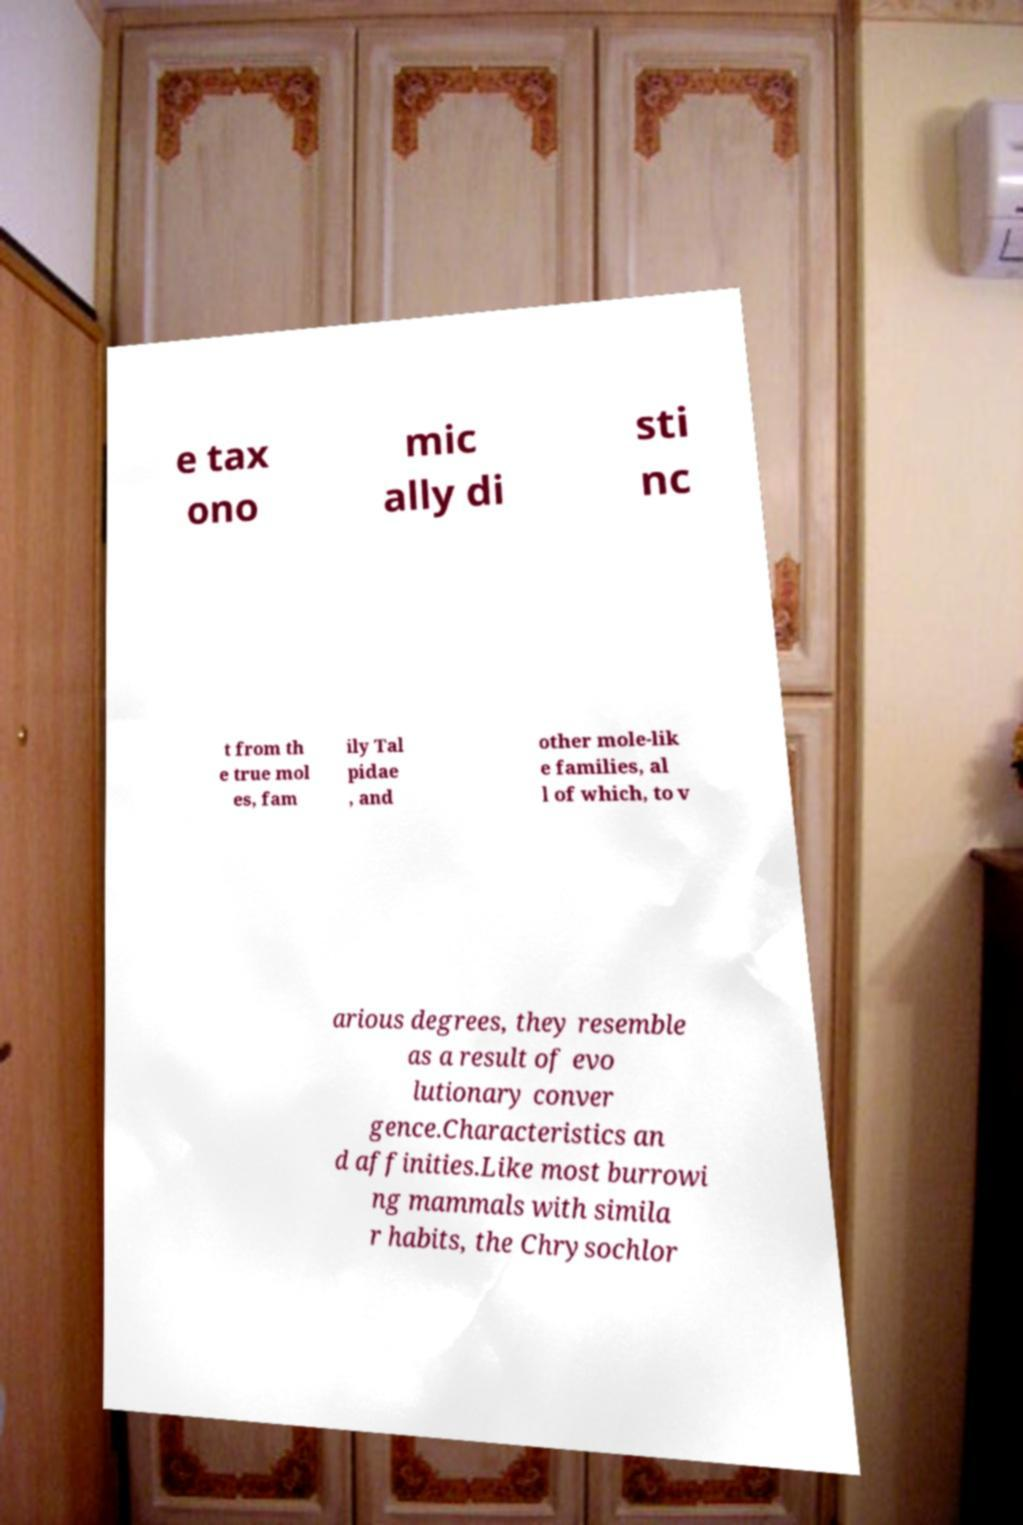I need the written content from this picture converted into text. Can you do that? e tax ono mic ally di sti nc t from th e true mol es, fam ily Tal pidae , and other mole-lik e families, al l of which, to v arious degrees, they resemble as a result of evo lutionary conver gence.Characteristics an d affinities.Like most burrowi ng mammals with simila r habits, the Chrysochlor 